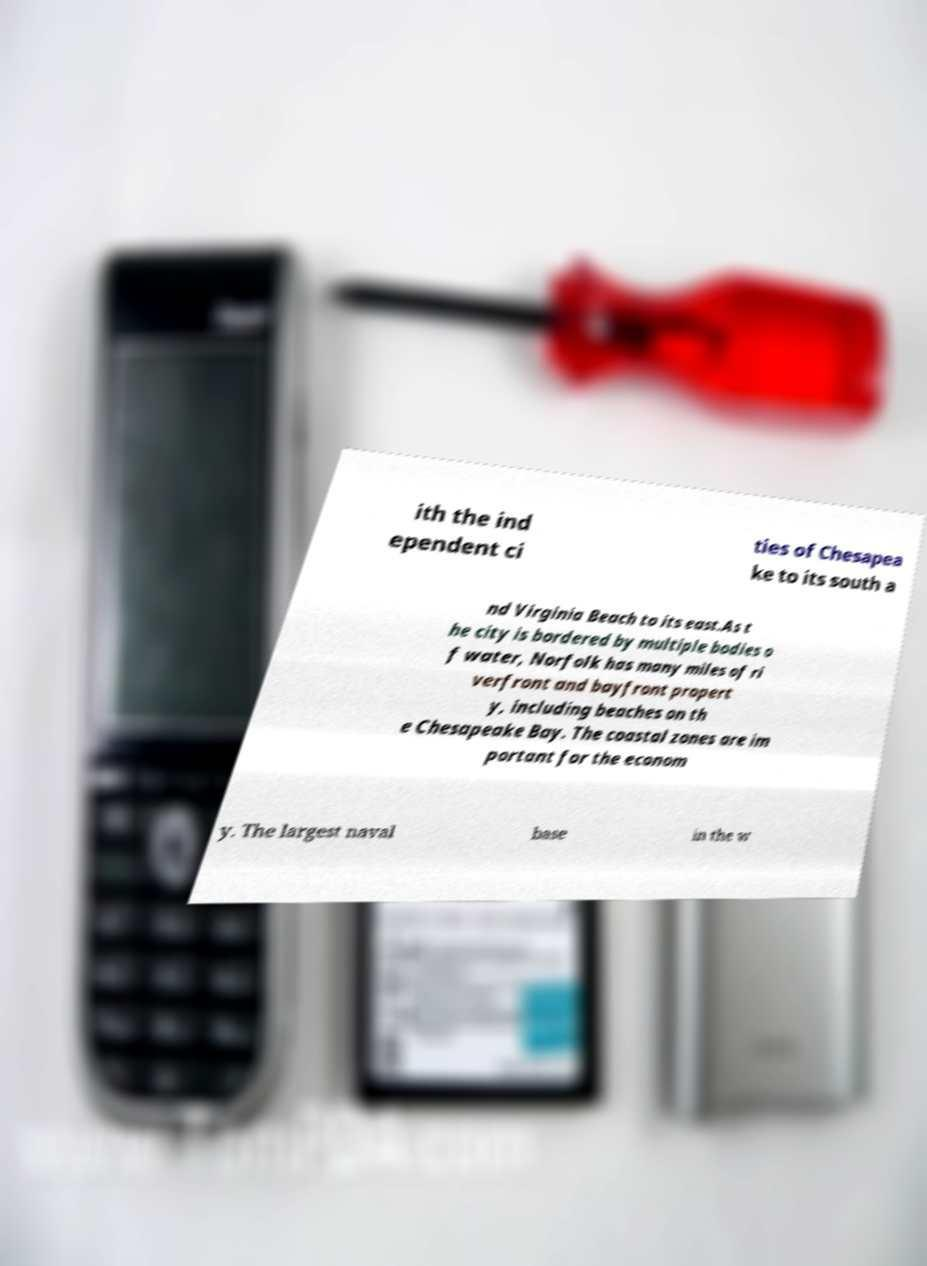Could you extract and type out the text from this image? ith the ind ependent ci ties of Chesapea ke to its south a nd Virginia Beach to its east.As t he city is bordered by multiple bodies o f water, Norfolk has many miles of ri verfront and bayfront propert y, including beaches on th e Chesapeake Bay. The coastal zones are im portant for the econom y. The largest naval base in the w 